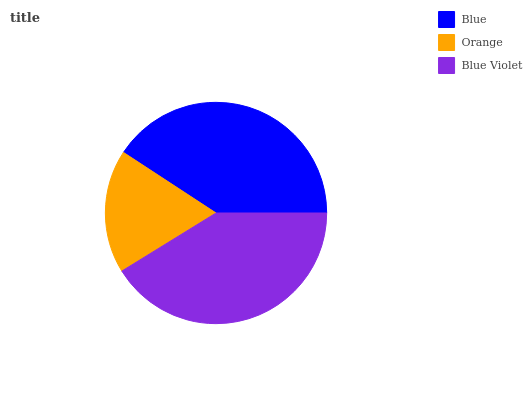Is Orange the minimum?
Answer yes or no. Yes. Is Blue Violet the maximum?
Answer yes or no. Yes. Is Blue Violet the minimum?
Answer yes or no. No. Is Orange the maximum?
Answer yes or no. No. Is Blue Violet greater than Orange?
Answer yes or no. Yes. Is Orange less than Blue Violet?
Answer yes or no. Yes. Is Orange greater than Blue Violet?
Answer yes or no. No. Is Blue Violet less than Orange?
Answer yes or no. No. Is Blue the high median?
Answer yes or no. Yes. Is Blue the low median?
Answer yes or no. Yes. Is Orange the high median?
Answer yes or no. No. Is Blue Violet the low median?
Answer yes or no. No. 